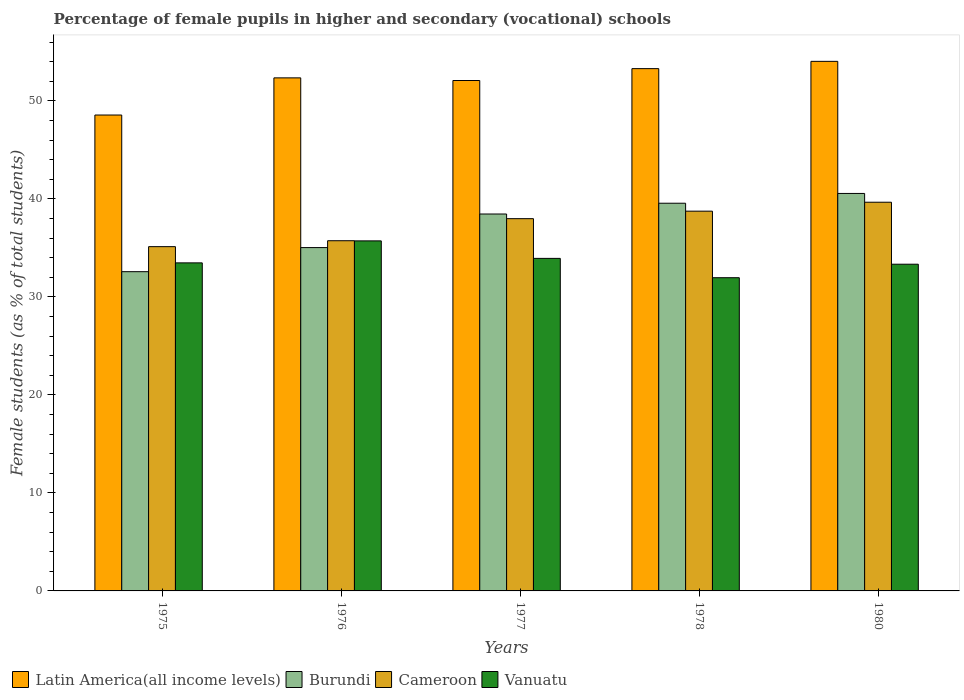How many different coloured bars are there?
Offer a very short reply. 4. How many groups of bars are there?
Provide a succinct answer. 5. Are the number of bars per tick equal to the number of legend labels?
Keep it short and to the point. Yes. How many bars are there on the 5th tick from the left?
Offer a terse response. 4. How many bars are there on the 3rd tick from the right?
Give a very brief answer. 4. What is the label of the 5th group of bars from the left?
Keep it short and to the point. 1980. In how many cases, is the number of bars for a given year not equal to the number of legend labels?
Your response must be concise. 0. What is the percentage of female pupils in higher and secondary schools in Cameroon in 1980?
Give a very brief answer. 39.66. Across all years, what is the maximum percentage of female pupils in higher and secondary schools in Vanuatu?
Keep it short and to the point. 35.71. Across all years, what is the minimum percentage of female pupils in higher and secondary schools in Cameroon?
Make the answer very short. 35.13. In which year was the percentage of female pupils in higher and secondary schools in Vanuatu maximum?
Provide a short and direct response. 1976. In which year was the percentage of female pupils in higher and secondary schools in Cameroon minimum?
Provide a short and direct response. 1975. What is the total percentage of female pupils in higher and secondary schools in Burundi in the graph?
Provide a succinct answer. 186.17. What is the difference between the percentage of female pupils in higher and secondary schools in Burundi in 1975 and that in 1977?
Make the answer very short. -5.88. What is the difference between the percentage of female pupils in higher and secondary schools in Vanuatu in 1977 and the percentage of female pupils in higher and secondary schools in Burundi in 1976?
Your answer should be compact. -1.1. What is the average percentage of female pupils in higher and secondary schools in Latin America(all income levels) per year?
Make the answer very short. 52.06. In the year 1978, what is the difference between the percentage of female pupils in higher and secondary schools in Cameroon and percentage of female pupils in higher and secondary schools in Vanuatu?
Keep it short and to the point. 6.79. In how many years, is the percentage of female pupils in higher and secondary schools in Vanuatu greater than 38 %?
Keep it short and to the point. 0. What is the ratio of the percentage of female pupils in higher and secondary schools in Latin America(all income levels) in 1975 to that in 1976?
Provide a succinct answer. 0.93. Is the percentage of female pupils in higher and secondary schools in Vanuatu in 1976 less than that in 1980?
Ensure brevity in your answer.  No. What is the difference between the highest and the second highest percentage of female pupils in higher and secondary schools in Cameroon?
Offer a terse response. 0.91. What is the difference between the highest and the lowest percentage of female pupils in higher and secondary schools in Cameroon?
Your answer should be very brief. 4.53. Is it the case that in every year, the sum of the percentage of female pupils in higher and secondary schools in Latin America(all income levels) and percentage of female pupils in higher and secondary schools in Cameroon is greater than the sum of percentage of female pupils in higher and secondary schools in Burundi and percentage of female pupils in higher and secondary schools in Vanuatu?
Offer a very short reply. Yes. What does the 4th bar from the left in 1976 represents?
Ensure brevity in your answer.  Vanuatu. What does the 1st bar from the right in 1978 represents?
Offer a terse response. Vanuatu. Is it the case that in every year, the sum of the percentage of female pupils in higher and secondary schools in Vanuatu and percentage of female pupils in higher and secondary schools in Cameroon is greater than the percentage of female pupils in higher and secondary schools in Latin America(all income levels)?
Keep it short and to the point. Yes. How many bars are there?
Keep it short and to the point. 20. What is the difference between two consecutive major ticks on the Y-axis?
Make the answer very short. 10. Are the values on the major ticks of Y-axis written in scientific E-notation?
Your response must be concise. No. Does the graph contain any zero values?
Your answer should be compact. No. Where does the legend appear in the graph?
Your answer should be compact. Bottom left. What is the title of the graph?
Your response must be concise. Percentage of female pupils in higher and secondary (vocational) schools. What is the label or title of the X-axis?
Offer a very short reply. Years. What is the label or title of the Y-axis?
Offer a terse response. Female students (as % of total students). What is the Female students (as % of total students) of Latin America(all income levels) in 1975?
Your response must be concise. 48.56. What is the Female students (as % of total students) in Burundi in 1975?
Your answer should be compact. 32.57. What is the Female students (as % of total students) of Cameroon in 1975?
Offer a terse response. 35.13. What is the Female students (as % of total students) of Vanuatu in 1975?
Ensure brevity in your answer.  33.47. What is the Female students (as % of total students) in Latin America(all income levels) in 1976?
Provide a succinct answer. 52.35. What is the Female students (as % of total students) of Burundi in 1976?
Offer a terse response. 35.03. What is the Female students (as % of total students) in Cameroon in 1976?
Keep it short and to the point. 35.73. What is the Female students (as % of total students) in Vanuatu in 1976?
Your answer should be very brief. 35.71. What is the Female students (as % of total students) of Latin America(all income levels) in 1977?
Your answer should be compact. 52.08. What is the Female students (as % of total students) of Burundi in 1977?
Your response must be concise. 38.46. What is the Female students (as % of total students) of Cameroon in 1977?
Provide a succinct answer. 37.98. What is the Female students (as % of total students) of Vanuatu in 1977?
Offer a very short reply. 33.93. What is the Female students (as % of total students) of Latin America(all income levels) in 1978?
Make the answer very short. 53.29. What is the Female students (as % of total students) of Burundi in 1978?
Keep it short and to the point. 39.56. What is the Female students (as % of total students) of Cameroon in 1978?
Ensure brevity in your answer.  38.75. What is the Female students (as % of total students) of Vanuatu in 1978?
Make the answer very short. 31.96. What is the Female students (as % of total students) of Latin America(all income levels) in 1980?
Make the answer very short. 54.03. What is the Female students (as % of total students) of Burundi in 1980?
Provide a succinct answer. 40.55. What is the Female students (as % of total students) of Cameroon in 1980?
Keep it short and to the point. 39.66. What is the Female students (as % of total students) of Vanuatu in 1980?
Your answer should be very brief. 33.33. Across all years, what is the maximum Female students (as % of total students) of Latin America(all income levels)?
Offer a terse response. 54.03. Across all years, what is the maximum Female students (as % of total students) of Burundi?
Offer a terse response. 40.55. Across all years, what is the maximum Female students (as % of total students) of Cameroon?
Your answer should be very brief. 39.66. Across all years, what is the maximum Female students (as % of total students) in Vanuatu?
Provide a short and direct response. 35.71. Across all years, what is the minimum Female students (as % of total students) in Latin America(all income levels)?
Give a very brief answer. 48.56. Across all years, what is the minimum Female students (as % of total students) of Burundi?
Provide a succinct answer. 32.57. Across all years, what is the minimum Female students (as % of total students) in Cameroon?
Keep it short and to the point. 35.13. Across all years, what is the minimum Female students (as % of total students) in Vanuatu?
Your response must be concise. 31.96. What is the total Female students (as % of total students) in Latin America(all income levels) in the graph?
Offer a terse response. 260.3. What is the total Female students (as % of total students) of Burundi in the graph?
Your answer should be very brief. 186.17. What is the total Female students (as % of total students) of Cameroon in the graph?
Your response must be concise. 187.24. What is the total Female students (as % of total students) in Vanuatu in the graph?
Your answer should be compact. 168.4. What is the difference between the Female students (as % of total students) of Latin America(all income levels) in 1975 and that in 1976?
Keep it short and to the point. -3.79. What is the difference between the Female students (as % of total students) of Burundi in 1975 and that in 1976?
Offer a terse response. -2.46. What is the difference between the Female students (as % of total students) in Cameroon in 1975 and that in 1976?
Keep it short and to the point. -0.6. What is the difference between the Female students (as % of total students) in Vanuatu in 1975 and that in 1976?
Provide a short and direct response. -2.24. What is the difference between the Female students (as % of total students) in Latin America(all income levels) in 1975 and that in 1977?
Your answer should be very brief. -3.52. What is the difference between the Female students (as % of total students) of Burundi in 1975 and that in 1977?
Keep it short and to the point. -5.88. What is the difference between the Female students (as % of total students) of Cameroon in 1975 and that in 1977?
Your answer should be very brief. -2.86. What is the difference between the Female students (as % of total students) in Vanuatu in 1975 and that in 1977?
Ensure brevity in your answer.  -0.46. What is the difference between the Female students (as % of total students) of Latin America(all income levels) in 1975 and that in 1978?
Provide a short and direct response. -4.73. What is the difference between the Female students (as % of total students) of Burundi in 1975 and that in 1978?
Ensure brevity in your answer.  -6.98. What is the difference between the Female students (as % of total students) of Cameroon in 1975 and that in 1978?
Provide a short and direct response. -3.62. What is the difference between the Female students (as % of total students) in Vanuatu in 1975 and that in 1978?
Offer a very short reply. 1.52. What is the difference between the Female students (as % of total students) in Latin America(all income levels) in 1975 and that in 1980?
Your answer should be very brief. -5.48. What is the difference between the Female students (as % of total students) in Burundi in 1975 and that in 1980?
Provide a succinct answer. -7.98. What is the difference between the Female students (as % of total students) of Cameroon in 1975 and that in 1980?
Make the answer very short. -4.53. What is the difference between the Female students (as % of total students) in Vanuatu in 1975 and that in 1980?
Offer a very short reply. 0.14. What is the difference between the Female students (as % of total students) of Latin America(all income levels) in 1976 and that in 1977?
Provide a succinct answer. 0.27. What is the difference between the Female students (as % of total students) in Burundi in 1976 and that in 1977?
Keep it short and to the point. -3.43. What is the difference between the Female students (as % of total students) of Cameroon in 1976 and that in 1977?
Provide a succinct answer. -2.25. What is the difference between the Female students (as % of total students) of Vanuatu in 1976 and that in 1977?
Give a very brief answer. 1.79. What is the difference between the Female students (as % of total students) of Latin America(all income levels) in 1976 and that in 1978?
Give a very brief answer. -0.94. What is the difference between the Female students (as % of total students) in Burundi in 1976 and that in 1978?
Offer a very short reply. -4.53. What is the difference between the Female students (as % of total students) in Cameroon in 1976 and that in 1978?
Provide a succinct answer. -3.02. What is the difference between the Female students (as % of total students) in Vanuatu in 1976 and that in 1978?
Make the answer very short. 3.76. What is the difference between the Female students (as % of total students) of Latin America(all income levels) in 1976 and that in 1980?
Keep it short and to the point. -1.68. What is the difference between the Female students (as % of total students) in Burundi in 1976 and that in 1980?
Your answer should be compact. -5.52. What is the difference between the Female students (as % of total students) in Cameroon in 1976 and that in 1980?
Your answer should be compact. -3.93. What is the difference between the Female students (as % of total students) in Vanuatu in 1976 and that in 1980?
Keep it short and to the point. 2.38. What is the difference between the Female students (as % of total students) of Latin America(all income levels) in 1977 and that in 1978?
Your answer should be compact. -1.21. What is the difference between the Female students (as % of total students) in Burundi in 1977 and that in 1978?
Your answer should be compact. -1.1. What is the difference between the Female students (as % of total students) of Cameroon in 1977 and that in 1978?
Your answer should be compact. -0.77. What is the difference between the Female students (as % of total students) of Vanuatu in 1977 and that in 1978?
Keep it short and to the point. 1.97. What is the difference between the Female students (as % of total students) of Latin America(all income levels) in 1977 and that in 1980?
Give a very brief answer. -1.95. What is the difference between the Female students (as % of total students) in Burundi in 1977 and that in 1980?
Your answer should be very brief. -2.1. What is the difference between the Female students (as % of total students) of Cameroon in 1977 and that in 1980?
Keep it short and to the point. -1.68. What is the difference between the Female students (as % of total students) in Vanuatu in 1977 and that in 1980?
Give a very brief answer. 0.6. What is the difference between the Female students (as % of total students) of Latin America(all income levels) in 1978 and that in 1980?
Make the answer very short. -0.74. What is the difference between the Female students (as % of total students) of Burundi in 1978 and that in 1980?
Offer a very short reply. -1. What is the difference between the Female students (as % of total students) of Cameroon in 1978 and that in 1980?
Make the answer very short. -0.91. What is the difference between the Female students (as % of total students) in Vanuatu in 1978 and that in 1980?
Offer a terse response. -1.38. What is the difference between the Female students (as % of total students) of Latin America(all income levels) in 1975 and the Female students (as % of total students) of Burundi in 1976?
Give a very brief answer. 13.52. What is the difference between the Female students (as % of total students) of Latin America(all income levels) in 1975 and the Female students (as % of total students) of Cameroon in 1976?
Give a very brief answer. 12.83. What is the difference between the Female students (as % of total students) of Latin America(all income levels) in 1975 and the Female students (as % of total students) of Vanuatu in 1976?
Give a very brief answer. 12.84. What is the difference between the Female students (as % of total students) in Burundi in 1975 and the Female students (as % of total students) in Cameroon in 1976?
Make the answer very short. -3.16. What is the difference between the Female students (as % of total students) in Burundi in 1975 and the Female students (as % of total students) in Vanuatu in 1976?
Give a very brief answer. -3.14. What is the difference between the Female students (as % of total students) in Cameroon in 1975 and the Female students (as % of total students) in Vanuatu in 1976?
Offer a terse response. -0.59. What is the difference between the Female students (as % of total students) in Latin America(all income levels) in 1975 and the Female students (as % of total students) in Burundi in 1977?
Offer a very short reply. 10.1. What is the difference between the Female students (as % of total students) in Latin America(all income levels) in 1975 and the Female students (as % of total students) in Cameroon in 1977?
Make the answer very short. 10.58. What is the difference between the Female students (as % of total students) in Latin America(all income levels) in 1975 and the Female students (as % of total students) in Vanuatu in 1977?
Ensure brevity in your answer.  14.63. What is the difference between the Female students (as % of total students) of Burundi in 1975 and the Female students (as % of total students) of Cameroon in 1977?
Make the answer very short. -5.41. What is the difference between the Female students (as % of total students) in Burundi in 1975 and the Female students (as % of total students) in Vanuatu in 1977?
Make the answer very short. -1.36. What is the difference between the Female students (as % of total students) of Cameroon in 1975 and the Female students (as % of total students) of Vanuatu in 1977?
Provide a short and direct response. 1.2. What is the difference between the Female students (as % of total students) in Latin America(all income levels) in 1975 and the Female students (as % of total students) in Burundi in 1978?
Give a very brief answer. 9. What is the difference between the Female students (as % of total students) of Latin America(all income levels) in 1975 and the Female students (as % of total students) of Cameroon in 1978?
Keep it short and to the point. 9.81. What is the difference between the Female students (as % of total students) in Latin America(all income levels) in 1975 and the Female students (as % of total students) in Vanuatu in 1978?
Offer a terse response. 16.6. What is the difference between the Female students (as % of total students) in Burundi in 1975 and the Female students (as % of total students) in Cameroon in 1978?
Ensure brevity in your answer.  -6.17. What is the difference between the Female students (as % of total students) of Burundi in 1975 and the Female students (as % of total students) of Vanuatu in 1978?
Offer a terse response. 0.62. What is the difference between the Female students (as % of total students) in Cameroon in 1975 and the Female students (as % of total students) in Vanuatu in 1978?
Ensure brevity in your answer.  3.17. What is the difference between the Female students (as % of total students) in Latin America(all income levels) in 1975 and the Female students (as % of total students) in Burundi in 1980?
Your answer should be compact. 8. What is the difference between the Female students (as % of total students) of Latin America(all income levels) in 1975 and the Female students (as % of total students) of Cameroon in 1980?
Ensure brevity in your answer.  8.9. What is the difference between the Female students (as % of total students) of Latin America(all income levels) in 1975 and the Female students (as % of total students) of Vanuatu in 1980?
Offer a terse response. 15.22. What is the difference between the Female students (as % of total students) in Burundi in 1975 and the Female students (as % of total students) in Cameroon in 1980?
Offer a terse response. -7.09. What is the difference between the Female students (as % of total students) of Burundi in 1975 and the Female students (as % of total students) of Vanuatu in 1980?
Your answer should be compact. -0.76. What is the difference between the Female students (as % of total students) of Cameroon in 1975 and the Female students (as % of total students) of Vanuatu in 1980?
Provide a short and direct response. 1.79. What is the difference between the Female students (as % of total students) in Latin America(all income levels) in 1976 and the Female students (as % of total students) in Burundi in 1977?
Give a very brief answer. 13.89. What is the difference between the Female students (as % of total students) in Latin America(all income levels) in 1976 and the Female students (as % of total students) in Cameroon in 1977?
Your answer should be very brief. 14.37. What is the difference between the Female students (as % of total students) in Latin America(all income levels) in 1976 and the Female students (as % of total students) in Vanuatu in 1977?
Your response must be concise. 18.42. What is the difference between the Female students (as % of total students) in Burundi in 1976 and the Female students (as % of total students) in Cameroon in 1977?
Offer a terse response. -2.95. What is the difference between the Female students (as % of total students) of Burundi in 1976 and the Female students (as % of total students) of Vanuatu in 1977?
Provide a short and direct response. 1.1. What is the difference between the Female students (as % of total students) of Cameroon in 1976 and the Female students (as % of total students) of Vanuatu in 1977?
Provide a succinct answer. 1.8. What is the difference between the Female students (as % of total students) of Latin America(all income levels) in 1976 and the Female students (as % of total students) of Burundi in 1978?
Ensure brevity in your answer.  12.79. What is the difference between the Female students (as % of total students) of Latin America(all income levels) in 1976 and the Female students (as % of total students) of Cameroon in 1978?
Your answer should be very brief. 13.6. What is the difference between the Female students (as % of total students) in Latin America(all income levels) in 1976 and the Female students (as % of total students) in Vanuatu in 1978?
Your answer should be compact. 20.39. What is the difference between the Female students (as % of total students) in Burundi in 1976 and the Female students (as % of total students) in Cameroon in 1978?
Offer a very short reply. -3.72. What is the difference between the Female students (as % of total students) of Burundi in 1976 and the Female students (as % of total students) of Vanuatu in 1978?
Your response must be concise. 3.07. What is the difference between the Female students (as % of total students) in Cameroon in 1976 and the Female students (as % of total students) in Vanuatu in 1978?
Provide a short and direct response. 3.77. What is the difference between the Female students (as % of total students) in Latin America(all income levels) in 1976 and the Female students (as % of total students) in Burundi in 1980?
Provide a short and direct response. 11.79. What is the difference between the Female students (as % of total students) of Latin America(all income levels) in 1976 and the Female students (as % of total students) of Cameroon in 1980?
Offer a very short reply. 12.69. What is the difference between the Female students (as % of total students) of Latin America(all income levels) in 1976 and the Female students (as % of total students) of Vanuatu in 1980?
Your response must be concise. 19.01. What is the difference between the Female students (as % of total students) in Burundi in 1976 and the Female students (as % of total students) in Cameroon in 1980?
Provide a succinct answer. -4.63. What is the difference between the Female students (as % of total students) of Burundi in 1976 and the Female students (as % of total students) of Vanuatu in 1980?
Your answer should be very brief. 1.7. What is the difference between the Female students (as % of total students) in Cameroon in 1976 and the Female students (as % of total students) in Vanuatu in 1980?
Make the answer very short. 2.4. What is the difference between the Female students (as % of total students) in Latin America(all income levels) in 1977 and the Female students (as % of total students) in Burundi in 1978?
Give a very brief answer. 12.52. What is the difference between the Female students (as % of total students) in Latin America(all income levels) in 1977 and the Female students (as % of total students) in Cameroon in 1978?
Ensure brevity in your answer.  13.33. What is the difference between the Female students (as % of total students) of Latin America(all income levels) in 1977 and the Female students (as % of total students) of Vanuatu in 1978?
Offer a terse response. 20.12. What is the difference between the Female students (as % of total students) of Burundi in 1977 and the Female students (as % of total students) of Cameroon in 1978?
Provide a short and direct response. -0.29. What is the difference between the Female students (as % of total students) of Burundi in 1977 and the Female students (as % of total students) of Vanuatu in 1978?
Provide a succinct answer. 6.5. What is the difference between the Female students (as % of total students) in Cameroon in 1977 and the Female students (as % of total students) in Vanuatu in 1978?
Your response must be concise. 6.02. What is the difference between the Female students (as % of total students) of Latin America(all income levels) in 1977 and the Female students (as % of total students) of Burundi in 1980?
Offer a very short reply. 11.52. What is the difference between the Female students (as % of total students) of Latin America(all income levels) in 1977 and the Female students (as % of total students) of Cameroon in 1980?
Offer a terse response. 12.42. What is the difference between the Female students (as % of total students) of Latin America(all income levels) in 1977 and the Female students (as % of total students) of Vanuatu in 1980?
Your answer should be compact. 18.74. What is the difference between the Female students (as % of total students) of Burundi in 1977 and the Female students (as % of total students) of Cameroon in 1980?
Your response must be concise. -1.2. What is the difference between the Female students (as % of total students) of Burundi in 1977 and the Female students (as % of total students) of Vanuatu in 1980?
Provide a short and direct response. 5.12. What is the difference between the Female students (as % of total students) in Cameroon in 1977 and the Female students (as % of total students) in Vanuatu in 1980?
Offer a terse response. 4.65. What is the difference between the Female students (as % of total students) of Latin America(all income levels) in 1978 and the Female students (as % of total students) of Burundi in 1980?
Your answer should be compact. 12.73. What is the difference between the Female students (as % of total students) in Latin America(all income levels) in 1978 and the Female students (as % of total students) in Cameroon in 1980?
Offer a terse response. 13.63. What is the difference between the Female students (as % of total students) of Latin America(all income levels) in 1978 and the Female students (as % of total students) of Vanuatu in 1980?
Offer a very short reply. 19.96. What is the difference between the Female students (as % of total students) in Burundi in 1978 and the Female students (as % of total students) in Cameroon in 1980?
Your answer should be compact. -0.1. What is the difference between the Female students (as % of total students) in Burundi in 1978 and the Female students (as % of total students) in Vanuatu in 1980?
Offer a very short reply. 6.22. What is the difference between the Female students (as % of total students) in Cameroon in 1978 and the Female students (as % of total students) in Vanuatu in 1980?
Make the answer very short. 5.41. What is the average Female students (as % of total students) of Latin America(all income levels) per year?
Your answer should be very brief. 52.06. What is the average Female students (as % of total students) of Burundi per year?
Offer a very short reply. 37.23. What is the average Female students (as % of total students) in Cameroon per year?
Provide a succinct answer. 37.45. What is the average Female students (as % of total students) of Vanuatu per year?
Provide a succinct answer. 33.68. In the year 1975, what is the difference between the Female students (as % of total students) in Latin America(all income levels) and Female students (as % of total students) in Burundi?
Your answer should be very brief. 15.98. In the year 1975, what is the difference between the Female students (as % of total students) in Latin America(all income levels) and Female students (as % of total students) in Cameroon?
Your response must be concise. 13.43. In the year 1975, what is the difference between the Female students (as % of total students) of Latin America(all income levels) and Female students (as % of total students) of Vanuatu?
Your answer should be compact. 15.08. In the year 1975, what is the difference between the Female students (as % of total students) in Burundi and Female students (as % of total students) in Cameroon?
Offer a terse response. -2.55. In the year 1975, what is the difference between the Female students (as % of total students) in Burundi and Female students (as % of total students) in Vanuatu?
Provide a succinct answer. -0.9. In the year 1975, what is the difference between the Female students (as % of total students) of Cameroon and Female students (as % of total students) of Vanuatu?
Your response must be concise. 1.65. In the year 1976, what is the difference between the Female students (as % of total students) in Latin America(all income levels) and Female students (as % of total students) in Burundi?
Your response must be concise. 17.32. In the year 1976, what is the difference between the Female students (as % of total students) of Latin America(all income levels) and Female students (as % of total students) of Cameroon?
Make the answer very short. 16.62. In the year 1976, what is the difference between the Female students (as % of total students) in Latin America(all income levels) and Female students (as % of total students) in Vanuatu?
Offer a terse response. 16.63. In the year 1976, what is the difference between the Female students (as % of total students) of Burundi and Female students (as % of total students) of Cameroon?
Offer a terse response. -0.7. In the year 1976, what is the difference between the Female students (as % of total students) in Burundi and Female students (as % of total students) in Vanuatu?
Offer a very short reply. -0.68. In the year 1976, what is the difference between the Female students (as % of total students) of Cameroon and Female students (as % of total students) of Vanuatu?
Make the answer very short. 0.02. In the year 1977, what is the difference between the Female students (as % of total students) of Latin America(all income levels) and Female students (as % of total students) of Burundi?
Make the answer very short. 13.62. In the year 1977, what is the difference between the Female students (as % of total students) in Latin America(all income levels) and Female students (as % of total students) in Cameroon?
Ensure brevity in your answer.  14.1. In the year 1977, what is the difference between the Female students (as % of total students) of Latin America(all income levels) and Female students (as % of total students) of Vanuatu?
Your answer should be compact. 18.15. In the year 1977, what is the difference between the Female students (as % of total students) of Burundi and Female students (as % of total students) of Cameroon?
Your response must be concise. 0.48. In the year 1977, what is the difference between the Female students (as % of total students) in Burundi and Female students (as % of total students) in Vanuatu?
Ensure brevity in your answer.  4.53. In the year 1977, what is the difference between the Female students (as % of total students) of Cameroon and Female students (as % of total students) of Vanuatu?
Keep it short and to the point. 4.05. In the year 1978, what is the difference between the Female students (as % of total students) in Latin America(all income levels) and Female students (as % of total students) in Burundi?
Your answer should be very brief. 13.73. In the year 1978, what is the difference between the Female students (as % of total students) of Latin America(all income levels) and Female students (as % of total students) of Cameroon?
Give a very brief answer. 14.54. In the year 1978, what is the difference between the Female students (as % of total students) of Latin America(all income levels) and Female students (as % of total students) of Vanuatu?
Offer a terse response. 21.33. In the year 1978, what is the difference between the Female students (as % of total students) of Burundi and Female students (as % of total students) of Cameroon?
Provide a short and direct response. 0.81. In the year 1978, what is the difference between the Female students (as % of total students) in Burundi and Female students (as % of total students) in Vanuatu?
Provide a succinct answer. 7.6. In the year 1978, what is the difference between the Female students (as % of total students) in Cameroon and Female students (as % of total students) in Vanuatu?
Give a very brief answer. 6.79. In the year 1980, what is the difference between the Female students (as % of total students) in Latin America(all income levels) and Female students (as % of total students) in Burundi?
Your response must be concise. 13.48. In the year 1980, what is the difference between the Female students (as % of total students) of Latin America(all income levels) and Female students (as % of total students) of Cameroon?
Ensure brevity in your answer.  14.37. In the year 1980, what is the difference between the Female students (as % of total students) in Latin America(all income levels) and Female students (as % of total students) in Vanuatu?
Give a very brief answer. 20.7. In the year 1980, what is the difference between the Female students (as % of total students) in Burundi and Female students (as % of total students) in Cameroon?
Ensure brevity in your answer.  0.9. In the year 1980, what is the difference between the Female students (as % of total students) of Burundi and Female students (as % of total students) of Vanuatu?
Give a very brief answer. 7.22. In the year 1980, what is the difference between the Female students (as % of total students) in Cameroon and Female students (as % of total students) in Vanuatu?
Offer a terse response. 6.32. What is the ratio of the Female students (as % of total students) in Latin America(all income levels) in 1975 to that in 1976?
Offer a very short reply. 0.93. What is the ratio of the Female students (as % of total students) of Burundi in 1975 to that in 1976?
Make the answer very short. 0.93. What is the ratio of the Female students (as % of total students) of Cameroon in 1975 to that in 1976?
Offer a terse response. 0.98. What is the ratio of the Female students (as % of total students) of Vanuatu in 1975 to that in 1976?
Provide a succinct answer. 0.94. What is the ratio of the Female students (as % of total students) of Latin America(all income levels) in 1975 to that in 1977?
Your answer should be very brief. 0.93. What is the ratio of the Female students (as % of total students) in Burundi in 1975 to that in 1977?
Your answer should be compact. 0.85. What is the ratio of the Female students (as % of total students) of Cameroon in 1975 to that in 1977?
Your response must be concise. 0.92. What is the ratio of the Female students (as % of total students) of Vanuatu in 1975 to that in 1977?
Give a very brief answer. 0.99. What is the ratio of the Female students (as % of total students) of Latin America(all income levels) in 1975 to that in 1978?
Ensure brevity in your answer.  0.91. What is the ratio of the Female students (as % of total students) in Burundi in 1975 to that in 1978?
Provide a short and direct response. 0.82. What is the ratio of the Female students (as % of total students) of Cameroon in 1975 to that in 1978?
Your answer should be very brief. 0.91. What is the ratio of the Female students (as % of total students) of Vanuatu in 1975 to that in 1978?
Keep it short and to the point. 1.05. What is the ratio of the Female students (as % of total students) in Latin America(all income levels) in 1975 to that in 1980?
Your answer should be very brief. 0.9. What is the ratio of the Female students (as % of total students) of Burundi in 1975 to that in 1980?
Give a very brief answer. 0.8. What is the ratio of the Female students (as % of total students) of Cameroon in 1975 to that in 1980?
Ensure brevity in your answer.  0.89. What is the ratio of the Female students (as % of total students) of Latin America(all income levels) in 1976 to that in 1977?
Offer a very short reply. 1.01. What is the ratio of the Female students (as % of total students) of Burundi in 1976 to that in 1977?
Your response must be concise. 0.91. What is the ratio of the Female students (as % of total students) in Cameroon in 1976 to that in 1977?
Your response must be concise. 0.94. What is the ratio of the Female students (as % of total students) of Vanuatu in 1976 to that in 1977?
Provide a short and direct response. 1.05. What is the ratio of the Female students (as % of total students) in Latin America(all income levels) in 1976 to that in 1978?
Offer a terse response. 0.98. What is the ratio of the Female students (as % of total students) of Burundi in 1976 to that in 1978?
Your answer should be compact. 0.89. What is the ratio of the Female students (as % of total students) in Cameroon in 1976 to that in 1978?
Ensure brevity in your answer.  0.92. What is the ratio of the Female students (as % of total students) in Vanuatu in 1976 to that in 1978?
Your answer should be very brief. 1.12. What is the ratio of the Female students (as % of total students) of Latin America(all income levels) in 1976 to that in 1980?
Your response must be concise. 0.97. What is the ratio of the Female students (as % of total students) of Burundi in 1976 to that in 1980?
Offer a very short reply. 0.86. What is the ratio of the Female students (as % of total students) of Cameroon in 1976 to that in 1980?
Make the answer very short. 0.9. What is the ratio of the Female students (as % of total students) in Vanuatu in 1976 to that in 1980?
Your response must be concise. 1.07. What is the ratio of the Female students (as % of total students) in Latin America(all income levels) in 1977 to that in 1978?
Offer a terse response. 0.98. What is the ratio of the Female students (as % of total students) of Burundi in 1977 to that in 1978?
Offer a very short reply. 0.97. What is the ratio of the Female students (as % of total students) in Cameroon in 1977 to that in 1978?
Offer a very short reply. 0.98. What is the ratio of the Female students (as % of total students) of Vanuatu in 1977 to that in 1978?
Provide a short and direct response. 1.06. What is the ratio of the Female students (as % of total students) in Latin America(all income levels) in 1977 to that in 1980?
Provide a short and direct response. 0.96. What is the ratio of the Female students (as % of total students) of Burundi in 1977 to that in 1980?
Your answer should be very brief. 0.95. What is the ratio of the Female students (as % of total students) of Cameroon in 1977 to that in 1980?
Give a very brief answer. 0.96. What is the ratio of the Female students (as % of total students) in Vanuatu in 1977 to that in 1980?
Give a very brief answer. 1.02. What is the ratio of the Female students (as % of total students) of Latin America(all income levels) in 1978 to that in 1980?
Provide a short and direct response. 0.99. What is the ratio of the Female students (as % of total students) in Burundi in 1978 to that in 1980?
Provide a short and direct response. 0.98. What is the ratio of the Female students (as % of total students) of Vanuatu in 1978 to that in 1980?
Make the answer very short. 0.96. What is the difference between the highest and the second highest Female students (as % of total students) in Latin America(all income levels)?
Offer a terse response. 0.74. What is the difference between the highest and the second highest Female students (as % of total students) in Burundi?
Keep it short and to the point. 1. What is the difference between the highest and the second highest Female students (as % of total students) in Cameroon?
Ensure brevity in your answer.  0.91. What is the difference between the highest and the second highest Female students (as % of total students) in Vanuatu?
Provide a succinct answer. 1.79. What is the difference between the highest and the lowest Female students (as % of total students) in Latin America(all income levels)?
Ensure brevity in your answer.  5.48. What is the difference between the highest and the lowest Female students (as % of total students) of Burundi?
Your answer should be compact. 7.98. What is the difference between the highest and the lowest Female students (as % of total students) in Cameroon?
Provide a short and direct response. 4.53. What is the difference between the highest and the lowest Female students (as % of total students) of Vanuatu?
Keep it short and to the point. 3.76. 